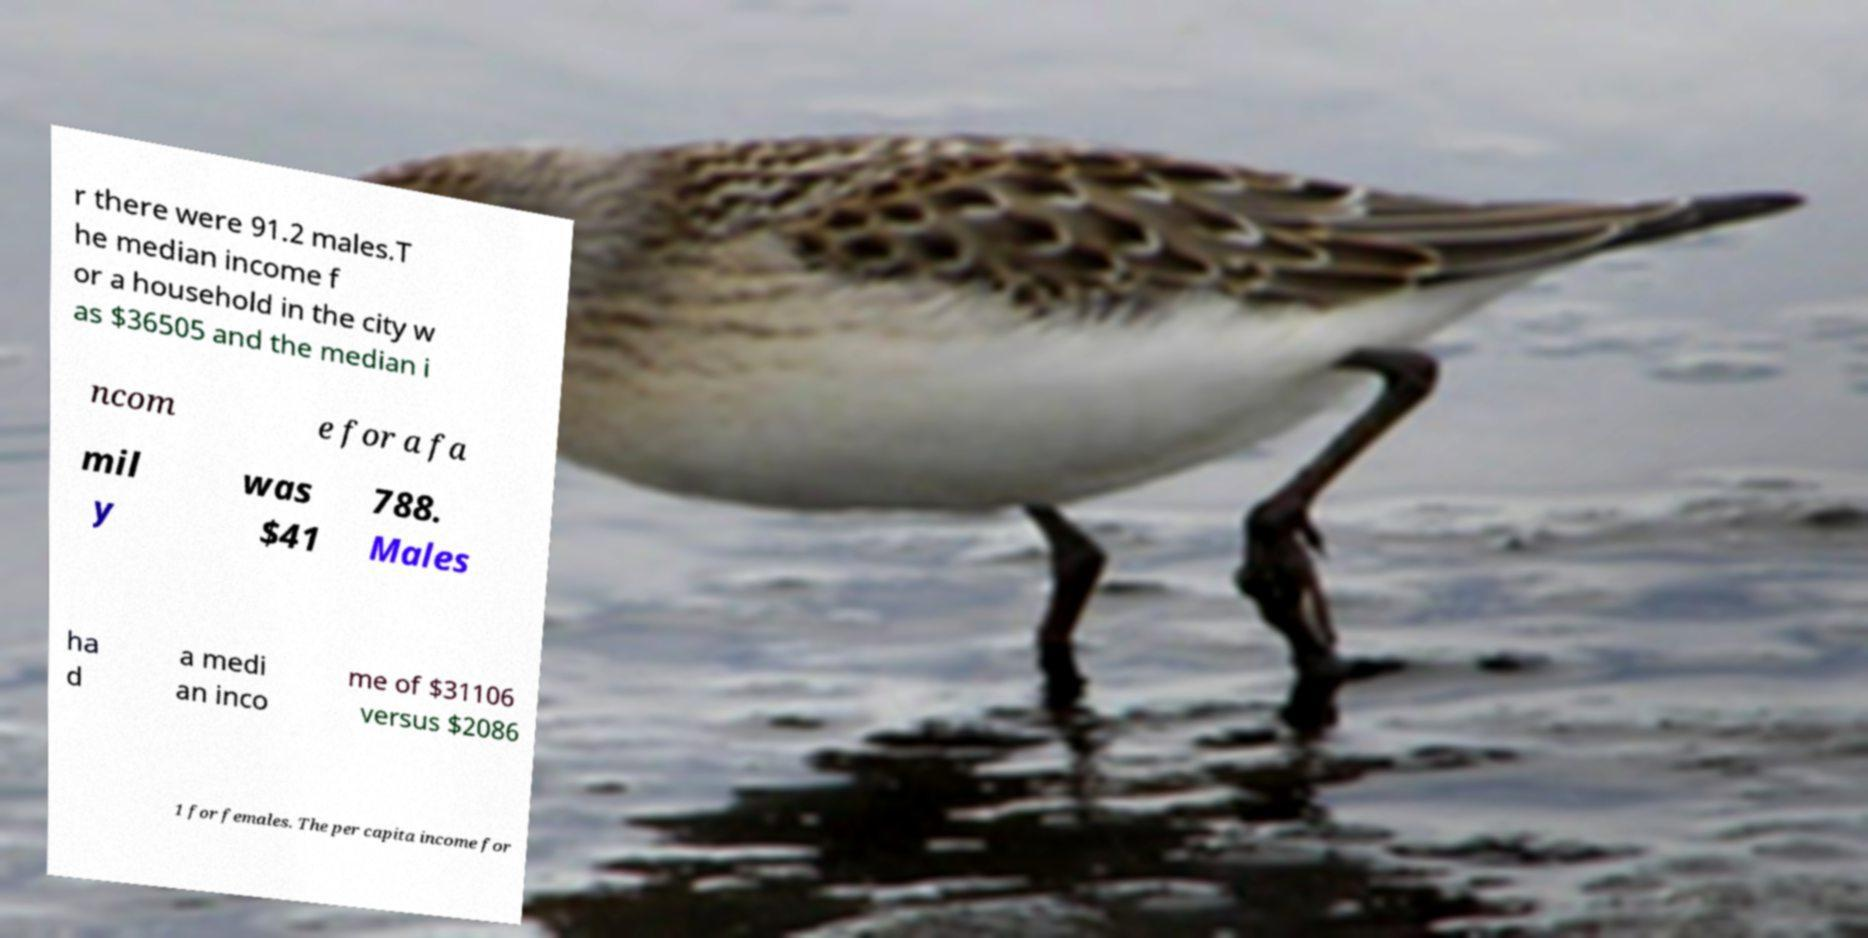There's text embedded in this image that I need extracted. Can you transcribe it verbatim? r there were 91.2 males.T he median income f or a household in the city w as $36505 and the median i ncom e for a fa mil y was $41 788. Males ha d a medi an inco me of $31106 versus $2086 1 for females. The per capita income for 